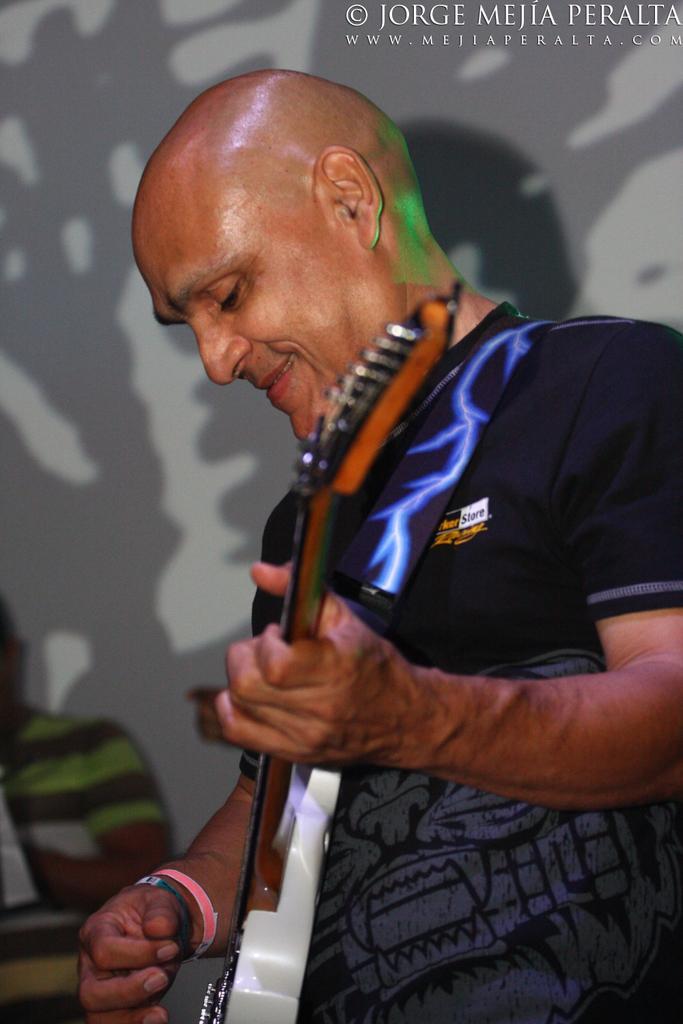Describe this image in one or two sentences. In this image I can see a man is playing the guitar, he wore black color t-shirt. There is a watermark at the top in this image. 